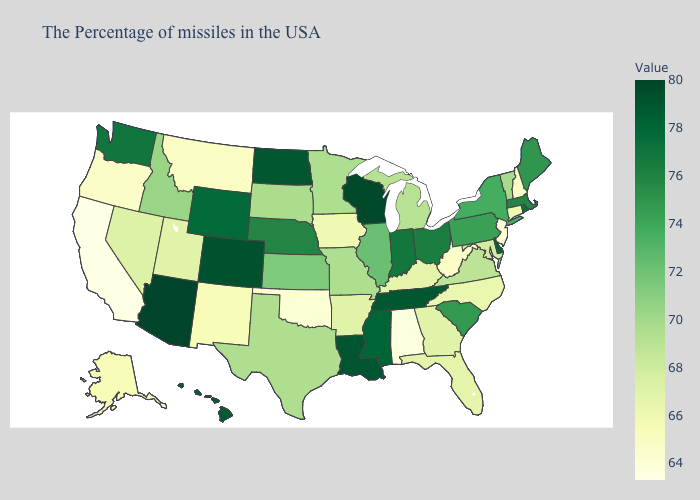Which states hav the highest value in the West?
Be succinct. Arizona. Among the states that border Arizona , which have the highest value?
Answer briefly. Colorado. Which states have the highest value in the USA?
Short answer required. Arizona. Does Oregon have a lower value than South Carolina?
Concise answer only. Yes. Which states have the lowest value in the USA?
Quick response, please. California. Does Connecticut have a higher value than Oklahoma?
Answer briefly. Yes. 